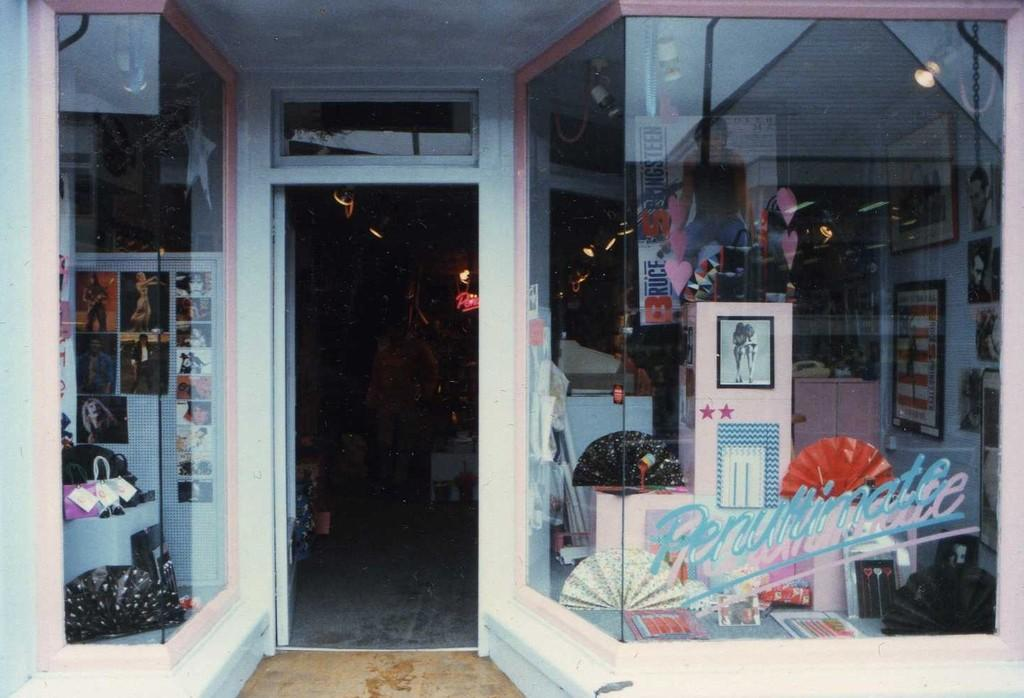What type of establishment is shown in the image? There is a store in the image. What can be found inside the store? There are photographs in a glass box and photo frames in the store. Are there any trees or plantations visible in the image? No, there are no trees or plantations visible in the image. 